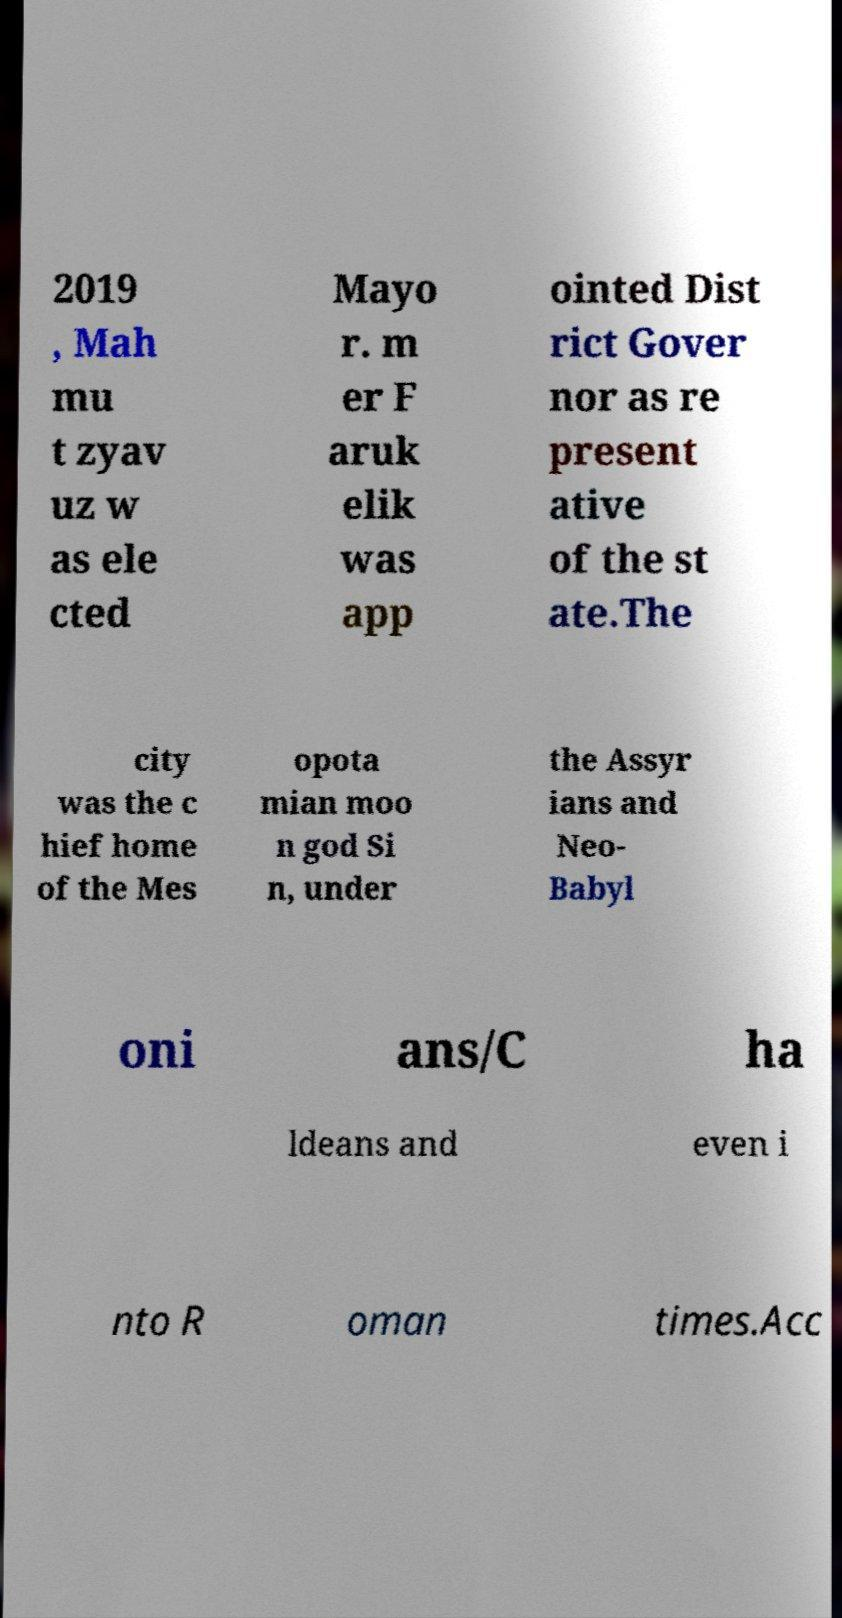Can you read and provide the text displayed in the image?This photo seems to have some interesting text. Can you extract and type it out for me? 2019 , Mah mu t zyav uz w as ele cted Mayo r. m er F aruk elik was app ointed Dist rict Gover nor as re present ative of the st ate.The city was the c hief home of the Mes opota mian moo n god Si n, under the Assyr ians and Neo- Babyl oni ans/C ha ldeans and even i nto R oman times.Acc 